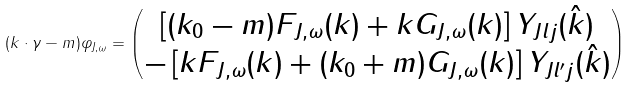<formula> <loc_0><loc_0><loc_500><loc_500>( k \cdot \gamma - m ) \varphi _ { J , \omega } = \begin{pmatrix} \left [ ( k _ { 0 } - m ) F _ { J , \omega } ( k ) + k G _ { J , \omega } ( k ) \right ] Y _ { J l j } ( \hat { k } ) \\ - \left [ k F _ { J , \omega } ( k ) + ( k _ { 0 } + m ) G _ { J , \omega } ( k ) \right ] Y _ { J l ^ { \prime } j } ( \hat { k } ) \end{pmatrix}</formula> 